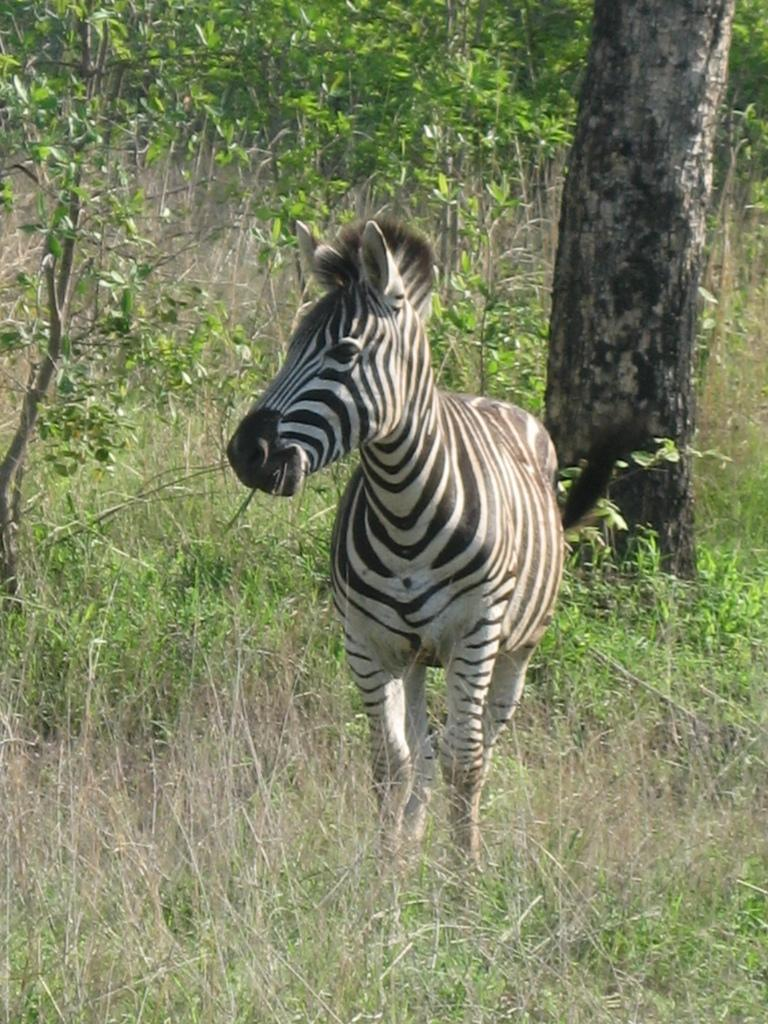Where was the picture taken? The picture was taken outside. What is the main subject of the image? There is a zebra in the center of the image. What is the zebra doing in the image? The zebra appears to be standing. What type of vegetation can be seen in the image? There is grass, plants, and trees visible in the image. What account number is associated with the book in the image? There is no book present in the image, and therefore no account number can be associated with it. 